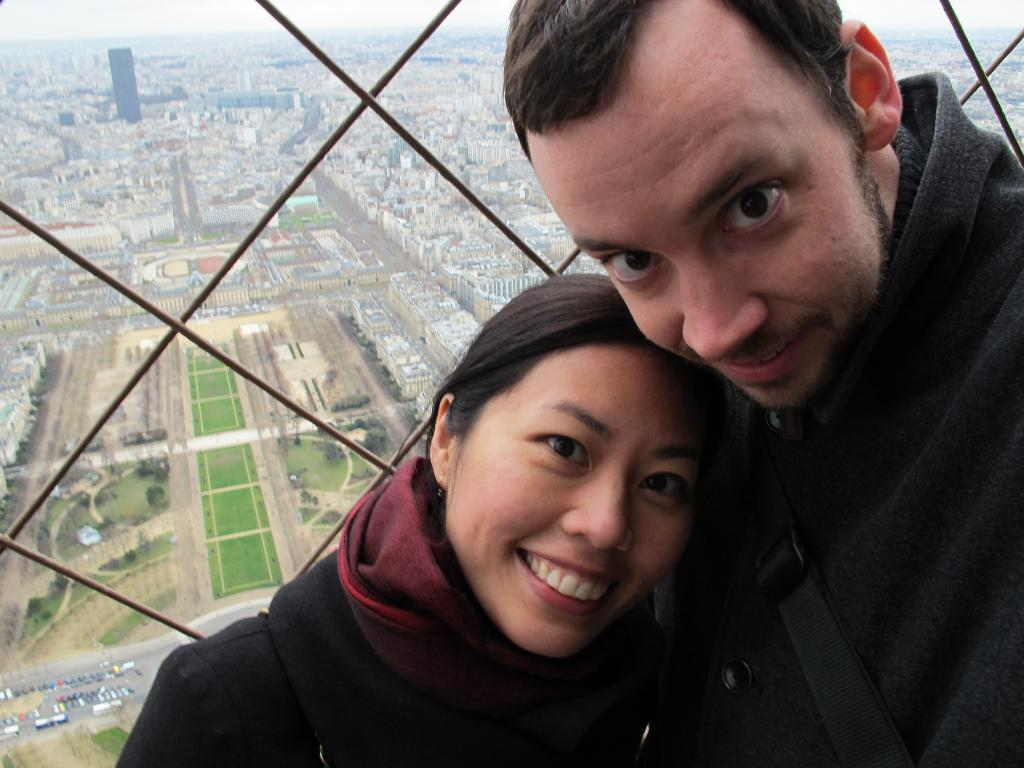How many people are in the image? There are two people in the image, a man and a woman. What are the man and woman wearing? Both the man and woman are wearing black dresses. What is behind the man and woman? They are standing in front of a glass wall. What can be seen in the background of the image? Many buildings are visible in the background. What type of vegetation is present on the left side of the land? The land has a garden on the left side. Can you tell me how many rays are emitted from the man's hands in the image? There are no rays emitted from the man's hands in the image; he is simply standing with the woman. 